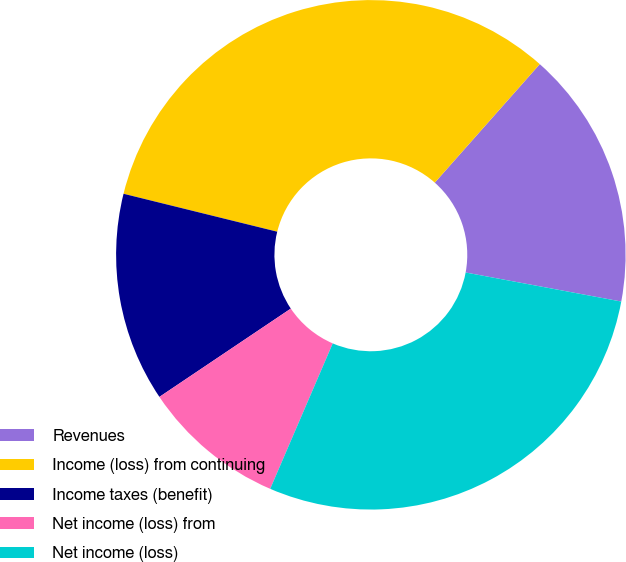Convert chart. <chart><loc_0><loc_0><loc_500><loc_500><pie_chart><fcel>Revenues<fcel>Income (loss) from continuing<fcel>Income taxes (benefit)<fcel>Net income (loss) from<fcel>Net income (loss)<nl><fcel>16.4%<fcel>32.69%<fcel>13.27%<fcel>9.12%<fcel>28.53%<nl></chart> 